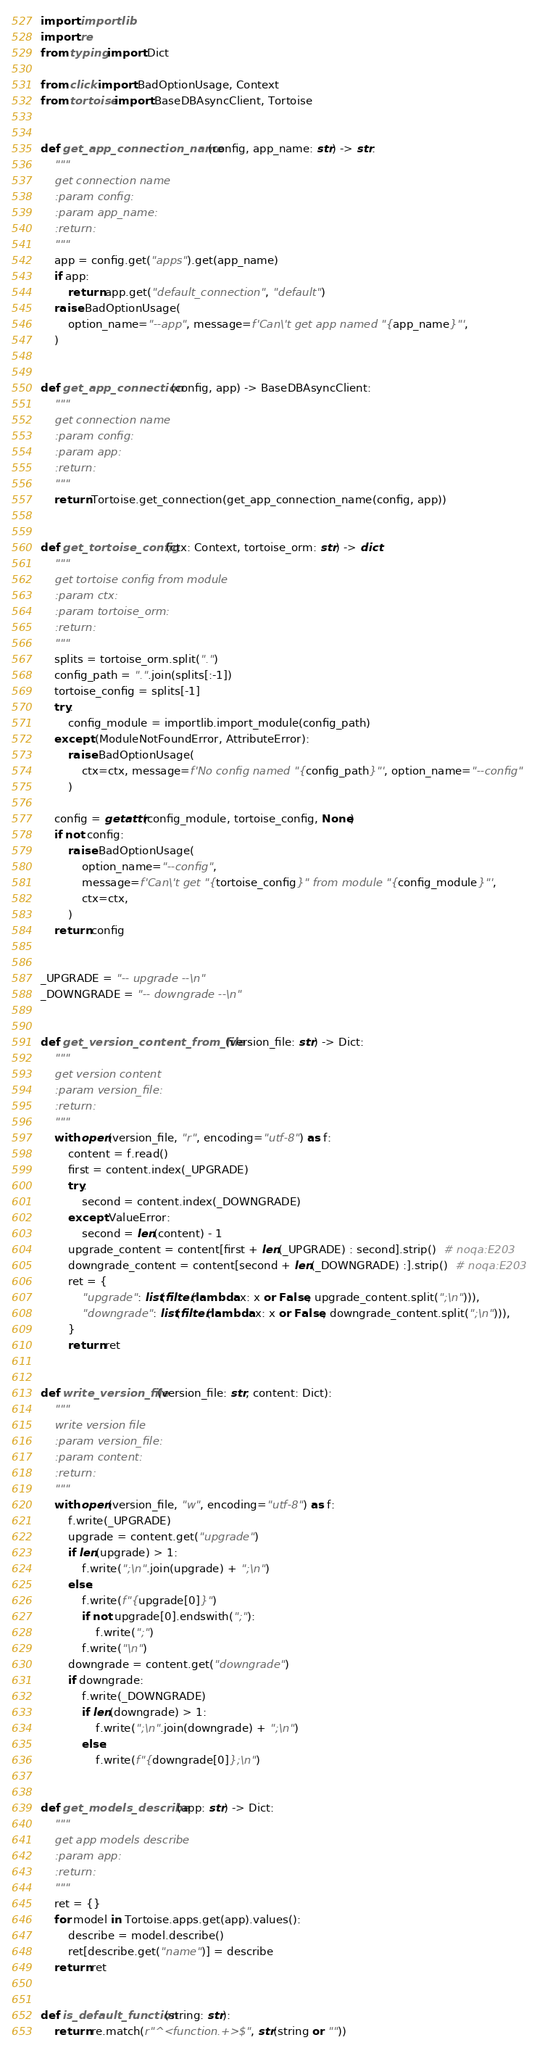<code> <loc_0><loc_0><loc_500><loc_500><_Python_>import importlib
import re
from typing import Dict

from click import BadOptionUsage, Context
from tortoise import BaseDBAsyncClient, Tortoise


def get_app_connection_name(config, app_name: str) -> str:
    """
    get connection name
    :param config:
    :param app_name:
    :return:
    """
    app = config.get("apps").get(app_name)
    if app:
        return app.get("default_connection", "default")
    raise BadOptionUsage(
        option_name="--app", message=f'Can\'t get app named "{app_name}"',
    )


def get_app_connection(config, app) -> BaseDBAsyncClient:
    """
    get connection name
    :param config:
    :param app:
    :return:
    """
    return Tortoise.get_connection(get_app_connection_name(config, app))


def get_tortoise_config(ctx: Context, tortoise_orm: str) -> dict:
    """
    get tortoise config from module
    :param ctx:
    :param tortoise_orm:
    :return:
    """
    splits = tortoise_orm.split(".")
    config_path = ".".join(splits[:-1])
    tortoise_config = splits[-1]
    try:
        config_module = importlib.import_module(config_path)
    except (ModuleNotFoundError, AttributeError):
        raise BadOptionUsage(
            ctx=ctx, message=f'No config named "{config_path}"', option_name="--config"
        )

    config = getattr(config_module, tortoise_config, None)
    if not config:
        raise BadOptionUsage(
            option_name="--config",
            message=f'Can\'t get "{tortoise_config}" from module "{config_module}"',
            ctx=ctx,
        )
    return config


_UPGRADE = "-- upgrade --\n"
_DOWNGRADE = "-- downgrade --\n"


def get_version_content_from_file(version_file: str) -> Dict:
    """
    get version content
    :param version_file:
    :return:
    """
    with open(version_file, "r", encoding="utf-8") as f:
        content = f.read()
        first = content.index(_UPGRADE)
        try:
            second = content.index(_DOWNGRADE)
        except ValueError:
            second = len(content) - 1
        upgrade_content = content[first + len(_UPGRADE) : second].strip()  # noqa:E203
        downgrade_content = content[second + len(_DOWNGRADE) :].strip()  # noqa:E203
        ret = {
            "upgrade": list(filter(lambda x: x or False, upgrade_content.split(";\n"))),
            "downgrade": list(filter(lambda x: x or False, downgrade_content.split(";\n"))),
        }
        return ret


def write_version_file(version_file: str, content: Dict):
    """
    write version file
    :param version_file:
    :param content:
    :return:
    """
    with open(version_file, "w", encoding="utf-8") as f:
        f.write(_UPGRADE)
        upgrade = content.get("upgrade")
        if len(upgrade) > 1:
            f.write(";\n".join(upgrade) + ";\n")
        else:
            f.write(f"{upgrade[0]}")
            if not upgrade[0].endswith(";"):
                f.write(";")
            f.write("\n")
        downgrade = content.get("downgrade")
        if downgrade:
            f.write(_DOWNGRADE)
            if len(downgrade) > 1:
                f.write(";\n".join(downgrade) + ";\n")
            else:
                f.write(f"{downgrade[0]};\n")


def get_models_describe(app: str) -> Dict:
    """
    get app models describe
    :param app:
    :return:
    """
    ret = {}
    for model in Tortoise.apps.get(app).values():
        describe = model.describe()
        ret[describe.get("name")] = describe
    return ret


def is_default_function(string: str):
    return re.match(r"^<function.+>$", str(string or ""))
</code> 